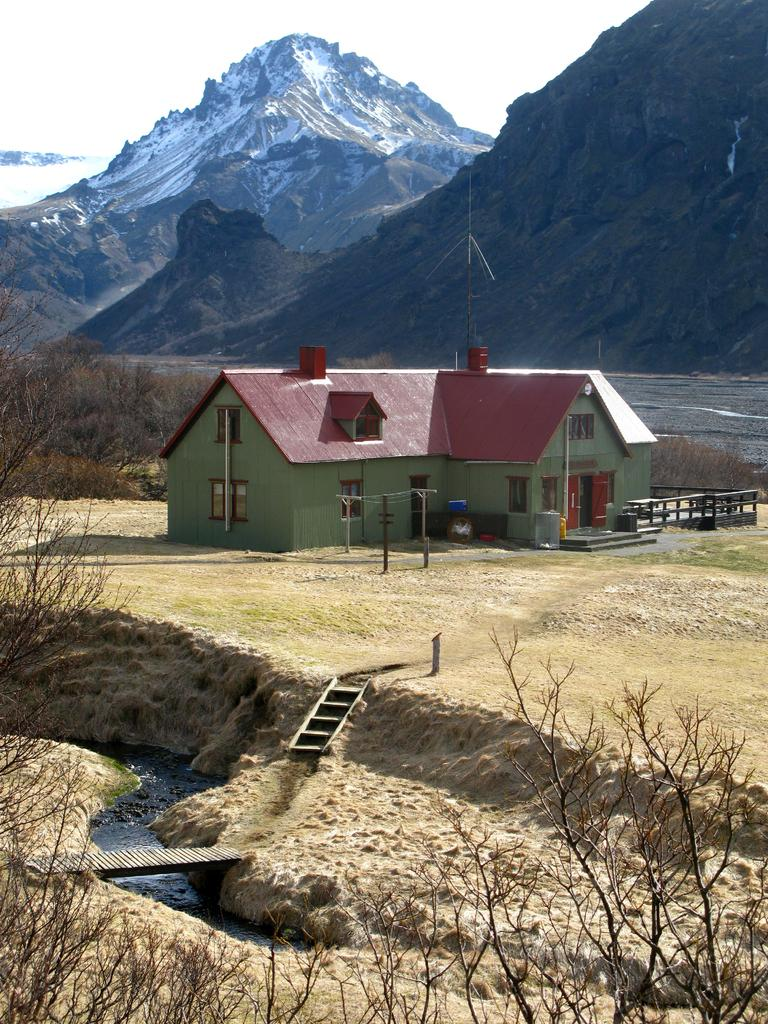What is the main structure in the center of the image? There is a house in the center of the image. What can be seen at the bottom of the image? Stairs, water, a bridge, and trees are visible at the bottom of the image. What is the landscape like in the background of the image? There are hills and the sky visible in the background of the image. How does the house take a breath in the image? Houses do not breathe, so this question is not applicable to the image. 